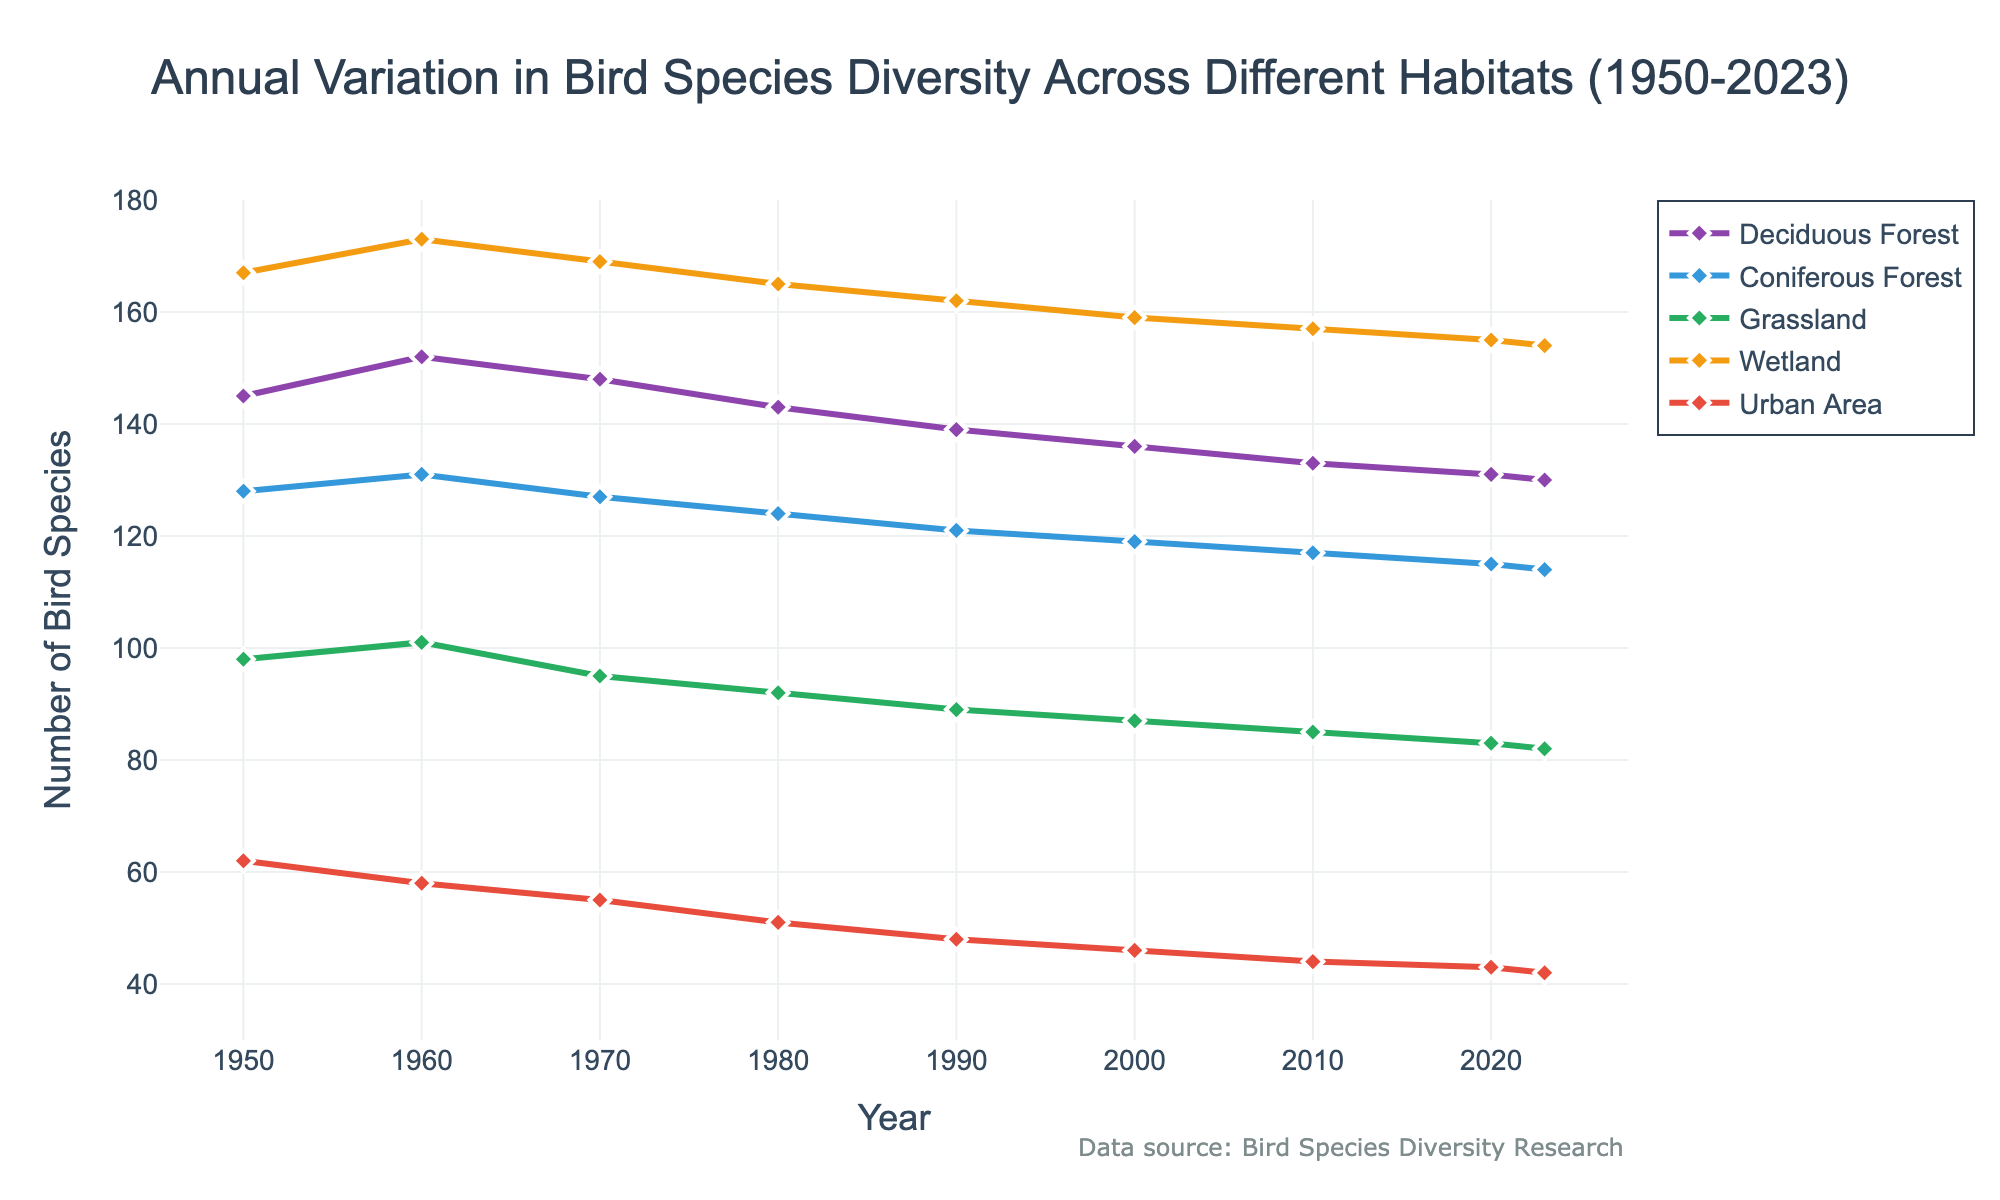Which habitat has shown a decrease in bird species diversity since 1950? Look at the trend of the lines since 1950; observe the slope and whether it is consistently downward. Deciduous Forest, Coniferous Forest, Grassland, Wetland, and Urban Area have all shown a decrease in the number of bird species.
Answer: Deciduous Forest, Coniferous Forest, Grassland, Wetland, Urban Area Compare the bird species diversity in Urban Area between 1950 and 2023. Which year shows a higher number? Identify the points corresponding to 1950 and 2023 on the Urban Area line and compare their values. In 1950, the value is 62, and in 2023, it is 42.
Answer: 1950 What is the difference between the bird species diversity in Grassland and Wetland in 1980? Identify the values for Grassland and Wetland in 1980. Grassland has 92 bird species, and Wetland has 165 bird species. Subtract the value for Grassland from the value for Wetland to find the difference: 165 - 92.
Answer: 73 In which habitat has the bird species diversity remained most stable from 1950 to 2023? Determine the habitat with the least change in bird species diversity over time by comparing the overall trends. Wetland has the least change, from 167 in 1950 to 154 in 2023, a change of only 13 species.
Answer: Wetland What is the average bird species diversity in the Deciduous Forest over the decades provided? Add up the values of Deciduous Forest for the years provided and then divide by the number of data points: (145 + 152 + 148 + 143 + 139 + 136 + 133 + 131 + 130) / 9. This equates to 1257 / 9.
Answer: 139.67 Which habitat shows the fastest decline in bird species diversity from 1950 to 2023? Calculate the rate of decline by determining the change in number of species divided by the number of years. Urban Area shows the fastest decline: (62 - 42) / (2023 - 1950) = -20 / 73 ≈ -0.27 species per year.
Answer: Urban Area What's the difference in bird species diversity between Coniferous Forest and Deciduous Forest in 2023? Identify the values for Coniferous Forest and Deciduous Forest in 2023. Coniferous Forest is 114 and Deciduous Forest is 130. Subtract one from the other: 130 - 114.
Answer: 16 How does the bird species diversity in Coniferous Forest in 2020 compare to that in 2000? Identify the values for Coniferous Forest in 2020 and 2000. Coniferous Forest has 115 species in 2020 and 119 in 2000. Comparing these values: 115 is less than 119.
Answer: Less than Which year shows the peak bird species diversity in Wetland? Locate the maximum value on the Wetland line and note the corresponding year. The peak occurs in 1960 with 173 species.
Answer: 1960 